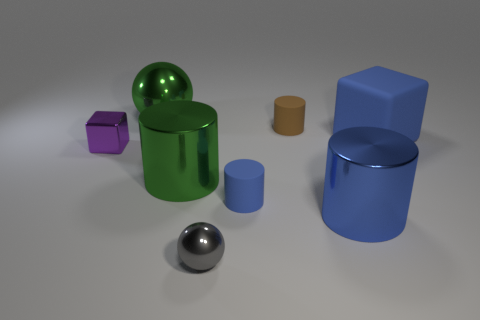There is a large metal thing that is the same color as the large block; what is its shape?
Ensure brevity in your answer.  Cylinder. Is there any other thing that is made of the same material as the green sphere?
Your response must be concise. Yes. What color is the other cylinder that is the same size as the blue matte cylinder?
Ensure brevity in your answer.  Brown. Are there any rubber things that have the same color as the large block?
Provide a short and direct response. Yes. There is a brown thing that is the same material as the big cube; what size is it?
Provide a succinct answer. Small. The other rubber thing that is the same color as the large rubber thing is what size?
Keep it short and to the point. Small. How many other objects are the same size as the blue matte cylinder?
Offer a terse response. 3. What is the tiny thing that is in front of the blue shiny thing made of?
Give a very brief answer. Metal. There is a green thing that is behind the big blue thing behind the large cylinder that is right of the tiny ball; what shape is it?
Ensure brevity in your answer.  Sphere. Do the gray metallic thing and the blue matte block have the same size?
Your answer should be compact. No. 